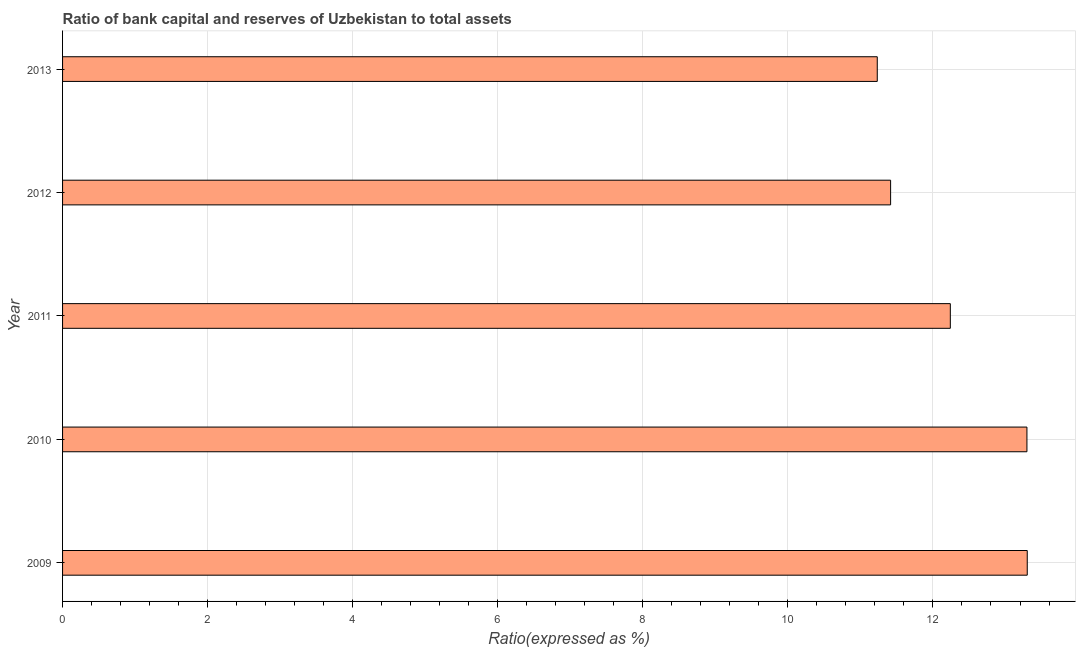Does the graph contain any zero values?
Your answer should be compact. No. What is the title of the graph?
Your response must be concise. Ratio of bank capital and reserves of Uzbekistan to total assets. What is the label or title of the X-axis?
Make the answer very short. Ratio(expressed as %). Across all years, what is the maximum bank capital to assets ratio?
Ensure brevity in your answer.  13.3. Across all years, what is the minimum bank capital to assets ratio?
Your answer should be compact. 11.23. What is the sum of the bank capital to assets ratio?
Offer a terse response. 61.48. What is the difference between the bank capital to assets ratio in 2010 and 2011?
Offer a very short reply. 1.06. What is the average bank capital to assets ratio per year?
Keep it short and to the point. 12.3. What is the median bank capital to assets ratio?
Provide a succinct answer. 12.24. In how many years, is the bank capital to assets ratio greater than 3.2 %?
Ensure brevity in your answer.  5. What is the ratio of the bank capital to assets ratio in 2010 to that in 2012?
Offer a terse response. 1.17. What is the difference between the highest and the second highest bank capital to assets ratio?
Keep it short and to the point. 0. Is the sum of the bank capital to assets ratio in 2010 and 2012 greater than the maximum bank capital to assets ratio across all years?
Keep it short and to the point. Yes. What is the difference between the highest and the lowest bank capital to assets ratio?
Your answer should be compact. 2.07. In how many years, is the bank capital to assets ratio greater than the average bank capital to assets ratio taken over all years?
Keep it short and to the point. 2. How many bars are there?
Your answer should be very brief. 5. Are the values on the major ticks of X-axis written in scientific E-notation?
Provide a succinct answer. No. What is the Ratio(expressed as %) in 2009?
Provide a short and direct response. 13.3. What is the Ratio(expressed as %) in 2010?
Keep it short and to the point. 13.3. What is the Ratio(expressed as %) of 2011?
Provide a short and direct response. 12.24. What is the Ratio(expressed as %) of 2012?
Your answer should be very brief. 11.42. What is the Ratio(expressed as %) of 2013?
Keep it short and to the point. 11.23. What is the difference between the Ratio(expressed as %) in 2009 and 2010?
Keep it short and to the point. 0. What is the difference between the Ratio(expressed as %) in 2009 and 2011?
Offer a very short reply. 1.06. What is the difference between the Ratio(expressed as %) in 2009 and 2012?
Provide a short and direct response. 1.88. What is the difference between the Ratio(expressed as %) in 2009 and 2013?
Your answer should be very brief. 2.07. What is the difference between the Ratio(expressed as %) in 2010 and 2011?
Keep it short and to the point. 1.06. What is the difference between the Ratio(expressed as %) in 2010 and 2012?
Keep it short and to the point. 1.88. What is the difference between the Ratio(expressed as %) in 2010 and 2013?
Ensure brevity in your answer.  2.06. What is the difference between the Ratio(expressed as %) in 2011 and 2012?
Your answer should be compact. 0.82. What is the difference between the Ratio(expressed as %) in 2011 and 2013?
Offer a very short reply. 1.01. What is the difference between the Ratio(expressed as %) in 2012 and 2013?
Provide a succinct answer. 0.18. What is the ratio of the Ratio(expressed as %) in 2009 to that in 2010?
Your answer should be compact. 1. What is the ratio of the Ratio(expressed as %) in 2009 to that in 2011?
Your response must be concise. 1.09. What is the ratio of the Ratio(expressed as %) in 2009 to that in 2012?
Give a very brief answer. 1.17. What is the ratio of the Ratio(expressed as %) in 2009 to that in 2013?
Offer a very short reply. 1.18. What is the ratio of the Ratio(expressed as %) in 2010 to that in 2011?
Offer a very short reply. 1.09. What is the ratio of the Ratio(expressed as %) in 2010 to that in 2012?
Offer a terse response. 1.17. What is the ratio of the Ratio(expressed as %) in 2010 to that in 2013?
Make the answer very short. 1.18. What is the ratio of the Ratio(expressed as %) in 2011 to that in 2012?
Provide a succinct answer. 1.07. What is the ratio of the Ratio(expressed as %) in 2011 to that in 2013?
Your answer should be compact. 1.09. What is the ratio of the Ratio(expressed as %) in 2012 to that in 2013?
Make the answer very short. 1.02. 